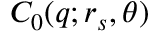<formula> <loc_0><loc_0><loc_500><loc_500>C _ { 0 } ( q ; r _ { s } , \theta )</formula> 